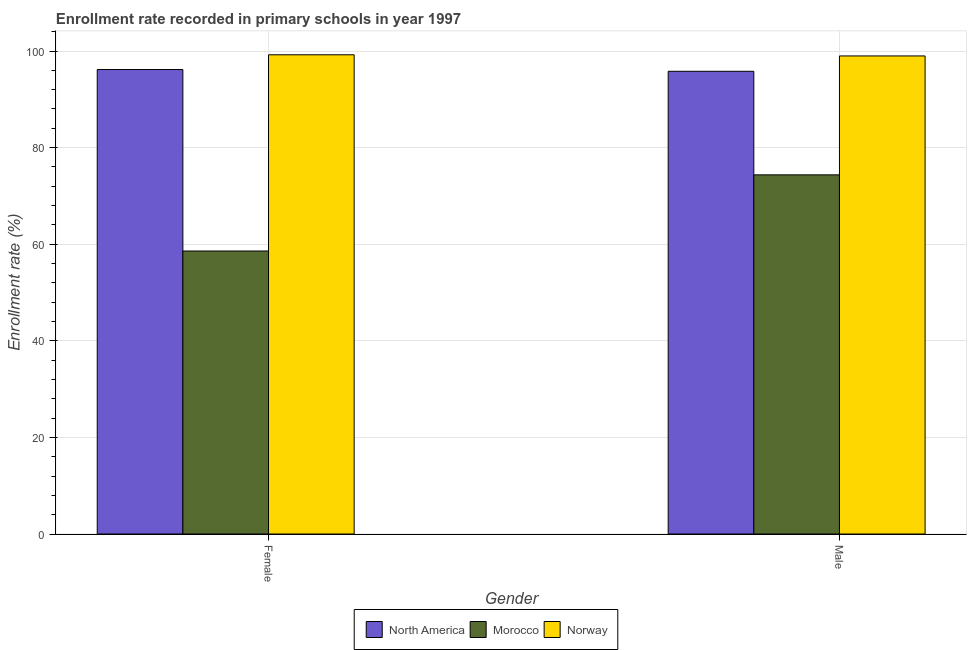How many different coloured bars are there?
Your answer should be very brief. 3. Are the number of bars per tick equal to the number of legend labels?
Offer a very short reply. Yes. How many bars are there on the 1st tick from the left?
Your answer should be very brief. 3. How many bars are there on the 2nd tick from the right?
Offer a terse response. 3. What is the label of the 2nd group of bars from the left?
Give a very brief answer. Male. What is the enrollment rate of female students in Norway?
Offer a very short reply. 99.23. Across all countries, what is the maximum enrollment rate of female students?
Offer a terse response. 99.23. Across all countries, what is the minimum enrollment rate of female students?
Your answer should be very brief. 58.59. In which country was the enrollment rate of male students maximum?
Give a very brief answer. Norway. In which country was the enrollment rate of female students minimum?
Your answer should be very brief. Morocco. What is the total enrollment rate of female students in the graph?
Provide a succinct answer. 253.99. What is the difference between the enrollment rate of female students in Norway and that in North America?
Provide a succinct answer. 3.05. What is the difference between the enrollment rate of female students in Morocco and the enrollment rate of male students in Norway?
Offer a terse response. -40.39. What is the average enrollment rate of male students per country?
Make the answer very short. 89.72. What is the difference between the enrollment rate of male students and enrollment rate of female students in Norway?
Provide a succinct answer. -0.24. What is the ratio of the enrollment rate of male students in North America to that in Morocco?
Make the answer very short. 1.29. Is the enrollment rate of female students in Morocco less than that in Norway?
Provide a succinct answer. Yes. In how many countries, is the enrollment rate of female students greater than the average enrollment rate of female students taken over all countries?
Offer a very short reply. 2. What does the 1st bar from the left in Male represents?
Give a very brief answer. North America. How many bars are there?
Offer a terse response. 6. Are all the bars in the graph horizontal?
Provide a short and direct response. No. How many countries are there in the graph?
Give a very brief answer. 3. Where does the legend appear in the graph?
Provide a short and direct response. Bottom center. How many legend labels are there?
Give a very brief answer. 3. What is the title of the graph?
Your answer should be very brief. Enrollment rate recorded in primary schools in year 1997. What is the label or title of the X-axis?
Provide a short and direct response. Gender. What is the label or title of the Y-axis?
Your answer should be compact. Enrollment rate (%). What is the Enrollment rate (%) of North America in Female?
Offer a very short reply. 96.17. What is the Enrollment rate (%) of Morocco in Female?
Provide a succinct answer. 58.59. What is the Enrollment rate (%) of Norway in Female?
Keep it short and to the point. 99.23. What is the Enrollment rate (%) of North America in Male?
Make the answer very short. 95.81. What is the Enrollment rate (%) in Morocco in Male?
Your response must be concise. 74.36. What is the Enrollment rate (%) in Norway in Male?
Your answer should be very brief. 98.99. Across all Gender, what is the maximum Enrollment rate (%) of North America?
Provide a succinct answer. 96.17. Across all Gender, what is the maximum Enrollment rate (%) of Morocco?
Provide a succinct answer. 74.36. Across all Gender, what is the maximum Enrollment rate (%) of Norway?
Provide a short and direct response. 99.23. Across all Gender, what is the minimum Enrollment rate (%) in North America?
Offer a terse response. 95.81. Across all Gender, what is the minimum Enrollment rate (%) of Morocco?
Your answer should be very brief. 58.59. Across all Gender, what is the minimum Enrollment rate (%) of Norway?
Ensure brevity in your answer.  98.99. What is the total Enrollment rate (%) in North America in the graph?
Offer a very short reply. 191.98. What is the total Enrollment rate (%) in Morocco in the graph?
Provide a succinct answer. 132.96. What is the total Enrollment rate (%) of Norway in the graph?
Your answer should be very brief. 198.21. What is the difference between the Enrollment rate (%) in North America in Female and that in Male?
Your response must be concise. 0.37. What is the difference between the Enrollment rate (%) in Morocco in Female and that in Male?
Your response must be concise. -15.77. What is the difference between the Enrollment rate (%) of Norway in Female and that in Male?
Keep it short and to the point. 0.24. What is the difference between the Enrollment rate (%) of North America in Female and the Enrollment rate (%) of Morocco in Male?
Provide a short and direct response. 21.81. What is the difference between the Enrollment rate (%) in North America in Female and the Enrollment rate (%) in Norway in Male?
Your answer should be very brief. -2.81. What is the difference between the Enrollment rate (%) of Morocco in Female and the Enrollment rate (%) of Norway in Male?
Your answer should be very brief. -40.39. What is the average Enrollment rate (%) in North America per Gender?
Provide a succinct answer. 95.99. What is the average Enrollment rate (%) in Morocco per Gender?
Offer a very short reply. 66.48. What is the average Enrollment rate (%) of Norway per Gender?
Your response must be concise. 99.11. What is the difference between the Enrollment rate (%) of North America and Enrollment rate (%) of Morocco in Female?
Your answer should be compact. 37.58. What is the difference between the Enrollment rate (%) in North America and Enrollment rate (%) in Norway in Female?
Your answer should be very brief. -3.05. What is the difference between the Enrollment rate (%) of Morocco and Enrollment rate (%) of Norway in Female?
Give a very brief answer. -40.63. What is the difference between the Enrollment rate (%) of North America and Enrollment rate (%) of Morocco in Male?
Your answer should be compact. 21.44. What is the difference between the Enrollment rate (%) in North America and Enrollment rate (%) in Norway in Male?
Keep it short and to the point. -3.18. What is the difference between the Enrollment rate (%) of Morocco and Enrollment rate (%) of Norway in Male?
Keep it short and to the point. -24.62. What is the ratio of the Enrollment rate (%) of North America in Female to that in Male?
Provide a short and direct response. 1. What is the ratio of the Enrollment rate (%) in Morocco in Female to that in Male?
Ensure brevity in your answer.  0.79. What is the difference between the highest and the second highest Enrollment rate (%) in North America?
Provide a short and direct response. 0.37. What is the difference between the highest and the second highest Enrollment rate (%) in Morocco?
Your response must be concise. 15.77. What is the difference between the highest and the second highest Enrollment rate (%) in Norway?
Offer a terse response. 0.24. What is the difference between the highest and the lowest Enrollment rate (%) in North America?
Provide a succinct answer. 0.37. What is the difference between the highest and the lowest Enrollment rate (%) of Morocco?
Your answer should be very brief. 15.77. What is the difference between the highest and the lowest Enrollment rate (%) in Norway?
Keep it short and to the point. 0.24. 